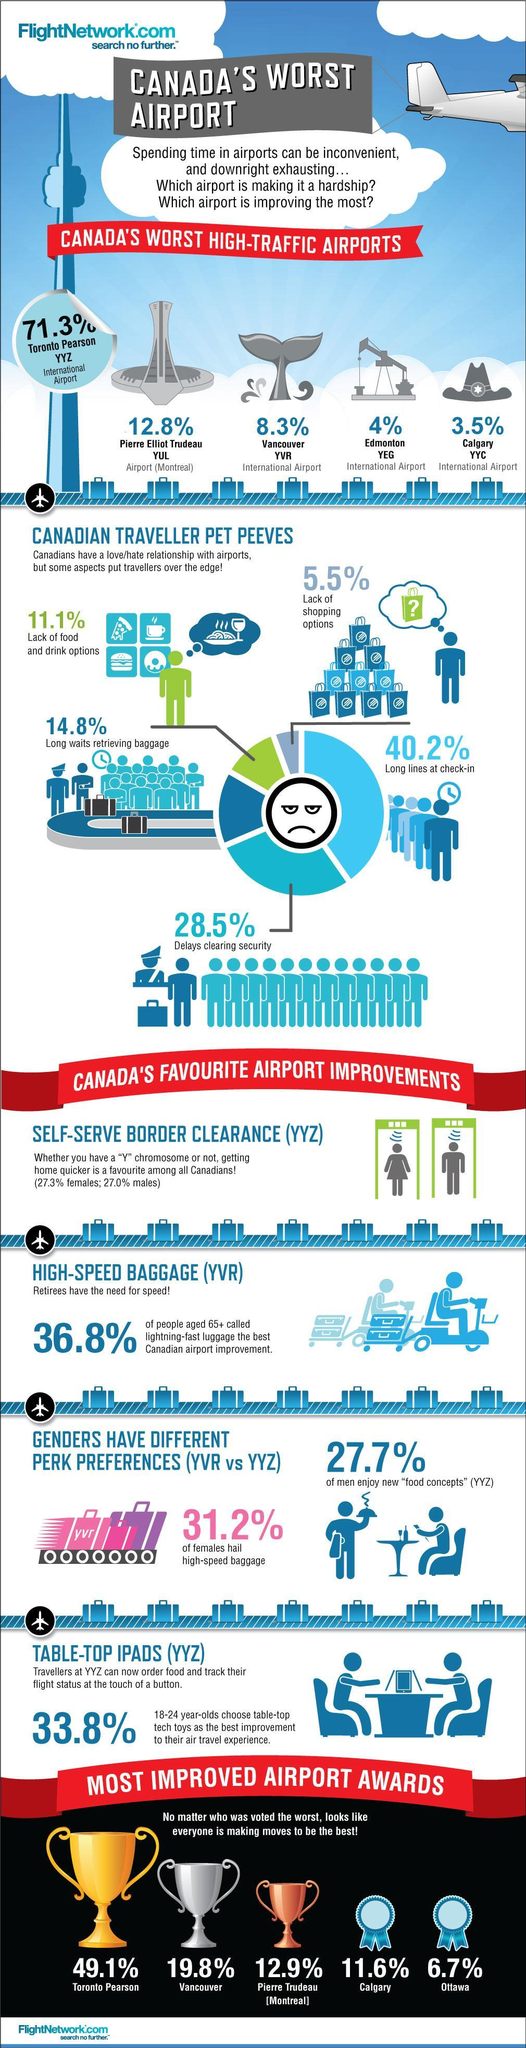What percentage of women like using self serve clearance?
Answer the question with a short phrase. 27.3% What is the second largest pet peeve according to Canadians at the airport? Delays clearing security Which airport has the golden cup for improvement? Toronto Pearson Which airport was voted the third best? Pierre Trudeau [Montreal] 